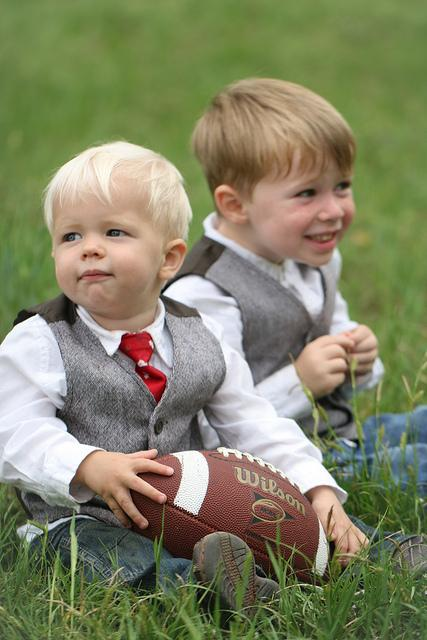What British sport could this ball be used for?

Choices:
A) rugby
B) soccer
C) bowls
D) golf rugby 